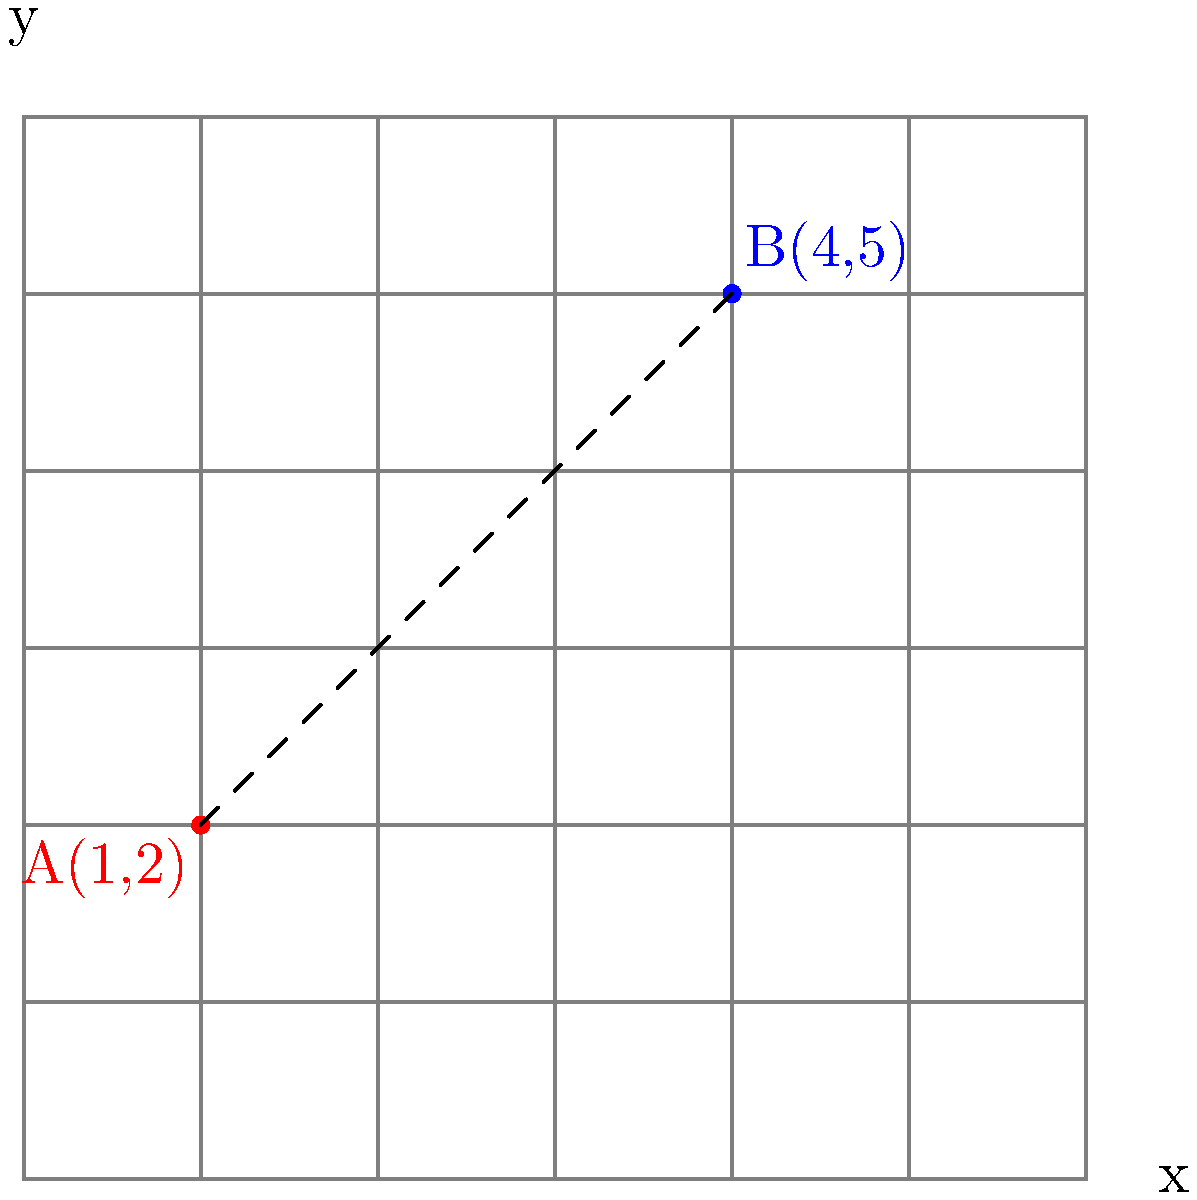In a comic book layout grid, point A represents the top-left corner of a panel, and point B represents the bottom-right corner. Given that A is located at coordinates (1,2) and B is at (4,5), calculate the distance between these two points to determine the diagonal length of the panel. Round your answer to two decimal places. To find the distance between two points, we can use the distance formula, which is derived from the Pythagorean theorem:

$$d = \sqrt{(x_2 - x_1)^2 + (y_2 - y_1)^2}$$

Where $(x_1, y_1)$ are the coordinates of point A, and $(x_2, y_2)$ are the coordinates of point B.

Let's plug in our values:
$x_1 = 1, y_1 = 2$
$x_2 = 4, y_2 = 5$

Now, let's calculate step by step:

1) First, find the differences:
   $x_2 - x_1 = 4 - 1 = 3$
   $y_2 - y_1 = 5 - 2 = 3$

2) Square these differences:
   $(x_2 - x_1)^2 = 3^2 = 9$
   $(y_2 - y_1)^2 = 3^2 = 9$

3) Add the squared differences:
   $9 + 9 = 18$

4) Take the square root:
   $d = \sqrt{18}$

5) Simplify:
   $d = 3\sqrt{2} \approx 4.24$

6) Round to two decimal places:
   $d \approx 4.24$

Therefore, the distance between points A and B, which represents the diagonal length of the comic book panel, is approximately 4.24 units on the layout grid.
Answer: 4.24 units 